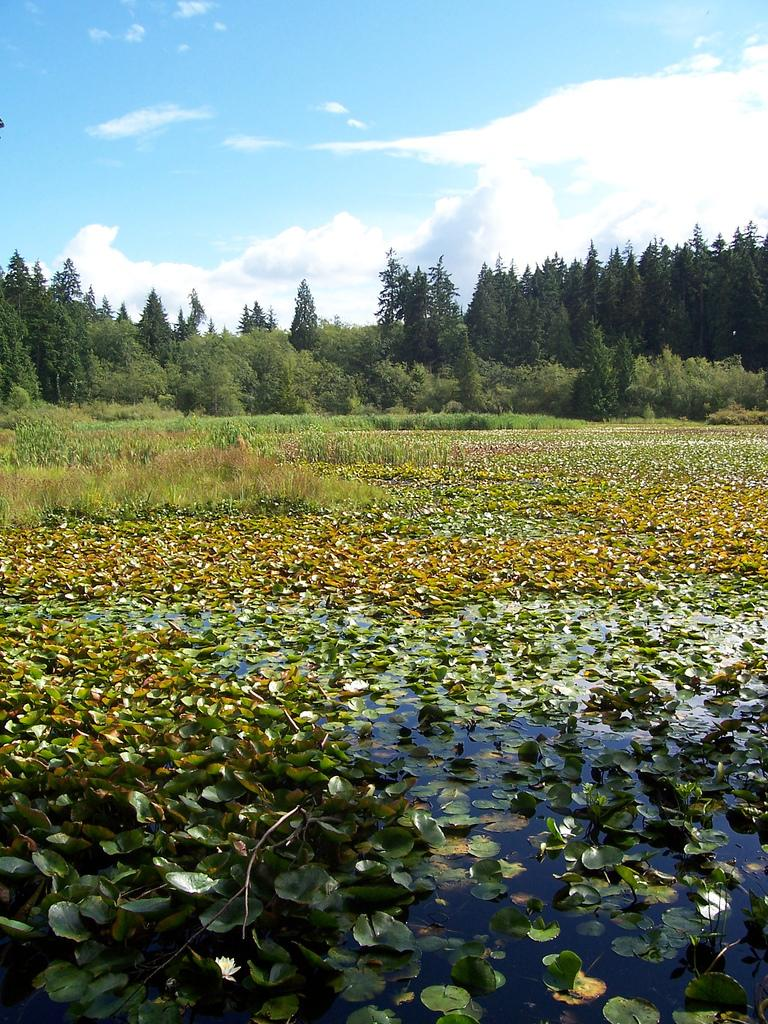What is the primary element visible in the image? There is water in the image. What is floating on the water? There are many leaves on the water. What can be seen in the background of the image? There are trees in the background of the image. What is the condition of the sky in the image? The sky is clear and visible in the background of the image. Where is the cobweb located in the image? There is no cobweb present in the image. What type of science experiment can be seen being conducted in the image? There is no science experiment or any indication of scientific activity in the image. 